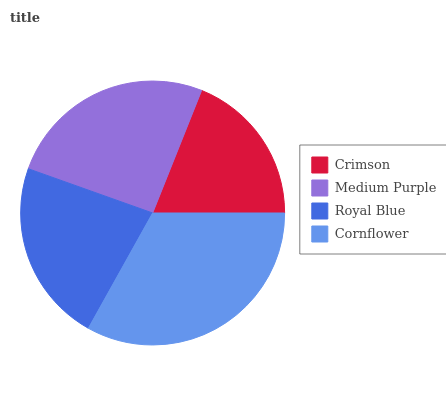Is Crimson the minimum?
Answer yes or no. Yes. Is Cornflower the maximum?
Answer yes or no. Yes. Is Medium Purple the minimum?
Answer yes or no. No. Is Medium Purple the maximum?
Answer yes or no. No. Is Medium Purple greater than Crimson?
Answer yes or no. Yes. Is Crimson less than Medium Purple?
Answer yes or no. Yes. Is Crimson greater than Medium Purple?
Answer yes or no. No. Is Medium Purple less than Crimson?
Answer yes or no. No. Is Medium Purple the high median?
Answer yes or no. Yes. Is Royal Blue the low median?
Answer yes or no. Yes. Is Royal Blue the high median?
Answer yes or no. No. Is Cornflower the low median?
Answer yes or no. No. 